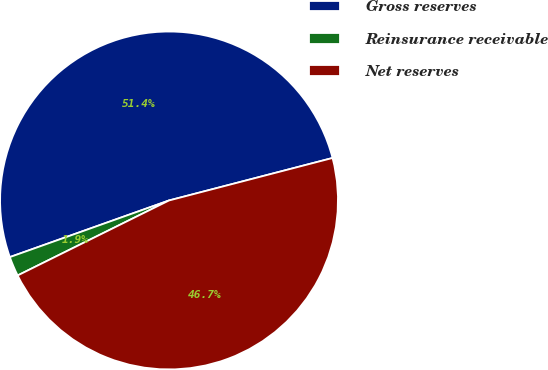<chart> <loc_0><loc_0><loc_500><loc_500><pie_chart><fcel>Gross reserves<fcel>Reinsurance receivable<fcel>Net reserves<nl><fcel>51.4%<fcel>1.88%<fcel>46.73%<nl></chart> 